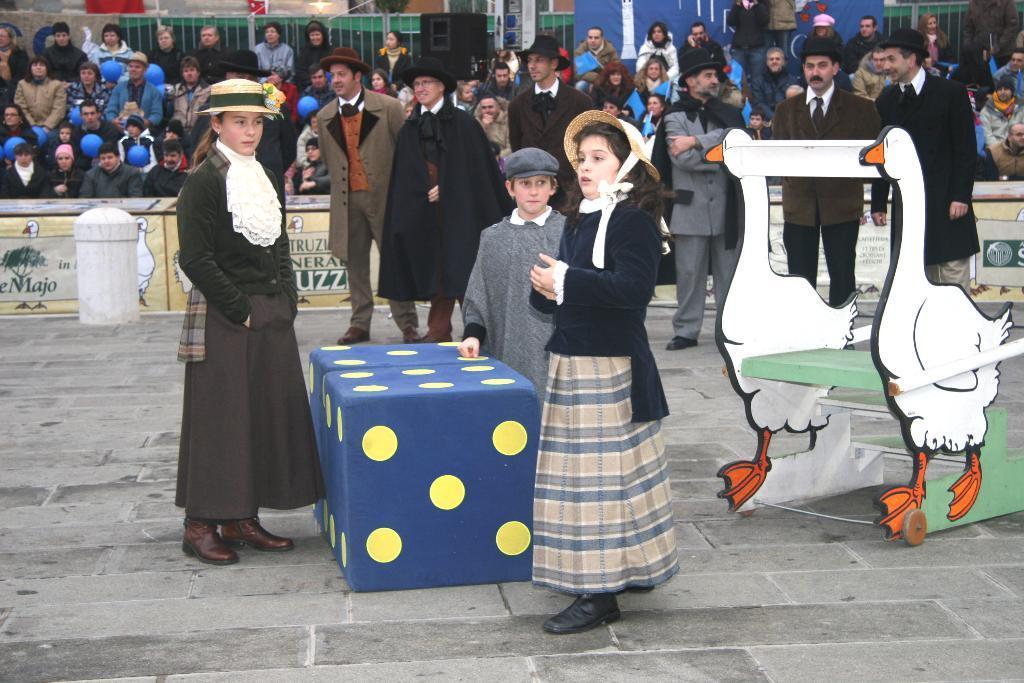How would you summarize this image in a sentence or two? In this Image I can see few people standing and wearing different color dress. I can see a blue and yellow boxes,white pole,few people sitting. In front I can see a duck vehicle. 